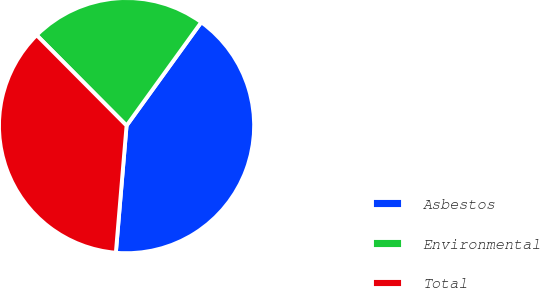<chart> <loc_0><loc_0><loc_500><loc_500><pie_chart><fcel>Asbestos<fcel>Environmental<fcel>Total<nl><fcel>41.38%<fcel>22.41%<fcel>36.21%<nl></chart> 